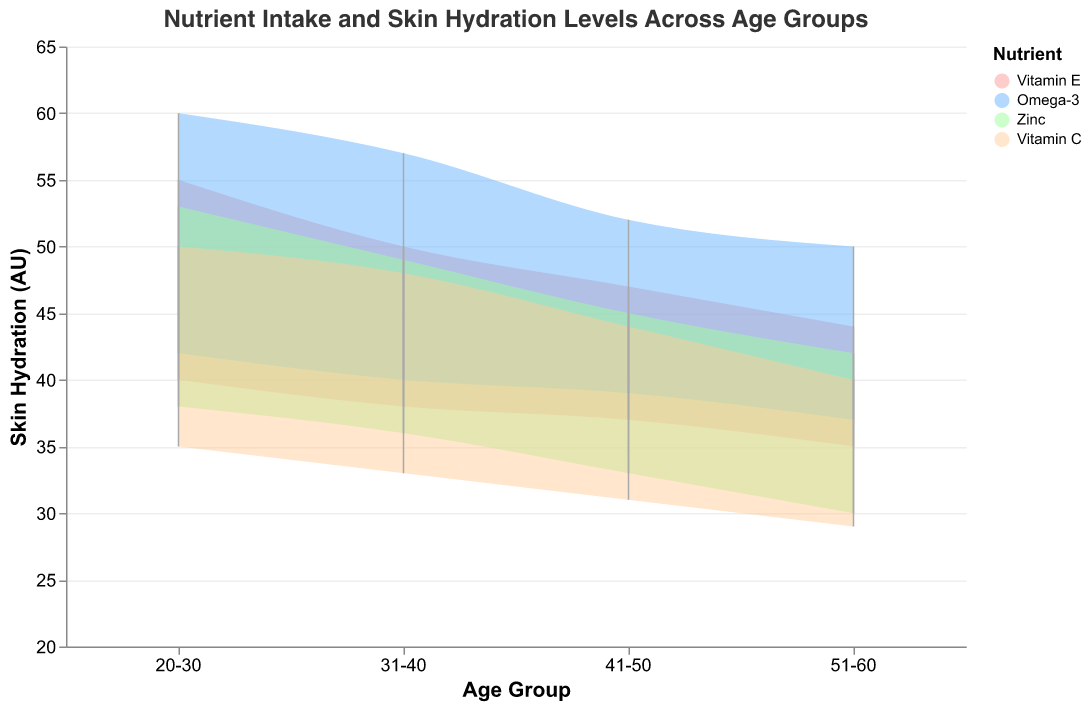What is the title of the chart? The title of the chart is displayed prominently at the top and describes the main purpose of the chart.
Answer: Nutrient Intake and Skin Hydration Levels Across Age Groups Which age group has the highest maximum skin hydration level? By observing the maximum skin hydration levels on the y-axis for each age group, we can compare the peak values. The highest maximum hydration level is evident in the age group where it reaches 60 AU.
Answer: 20-30 How does the range of Vitamin E intake change as age increases? To determine this, we examine the minimum and maximum intake values of Vitamin E from each age group and compare them. As age increases, the range shifts downward for both minimum and maximum intake levels. For instance, in the 20-30 age group, the range is from 8 to 15 mg/day, while in the 51-60 age group, it is from 5 to 12 mg/day.
Answer: It decreases Which nutrient shows the greatest variation in skin hydration levels in the 20-30 age group? The nutrient with the largest range between minimum and maximum skin hydration levels in the 20-30 age group is Omega-3, with a variation from 42 to 60 AU.
Answer: Omega-3 What is the minimum hydration level for the nutrient with the lowest maximum intake in the 41-50 age group? From the data, we see that Zinc has the lowest maximum intake (10 mg/day) in the 41-50 age group. The minimum skin hydration level for Zinc in this age group is 33 AU.
Answer: 33 AU How does the variation in minimum and maximum skin hydration levels for Omega-3 change between the 31-40 and 51-60 age groups? Comparing the ranges from the 31-40 (40-57 AU) and 51-60 (37-50 AU) age groups shows that the range decreases as age increases. Specifically, the variation decreases from 17 AU in 31-40 to 13 AU in 51-60.
Answer: It decreases What is the difference in maximum hydration levels between the nutrients Omega-3 and Vitamin C in the 31-40 age group? By looking at the maximum values for Omega-3 (57 AU) and Vitamin C (48 AU) in the 31-40 age group, we subtract to find the difference: 57 - 48.
Answer: 9 AU Which nutrient has the smallest range of skin hydration levels in the 51-60 age group? By comparing the min and max skin hydration levels for each nutrient in the 51-60 age group, we identify that Zinc has the smallest range (30-42 AU).
Answer: Zinc Is there any age group where the minimum skin hydration level for Vitamin C is higher than the maximum skin hydration level for Zinc? To determine this, we compare the minimum hydration levels of Vitamin C with the maximum hydration levels of Zinc across all age groups. No such case exists where the minimum hydration level of Vitamin C is higher than the maximum hydration level for Zinc.
Answer: No In which age group does Vitamin E have the closest minimum and maximum intake values? Looking at the intake ranges for Vitamin E across age groups, we see the 41-50 age group has the closest values (6 to 13 mg/day), with a range difference of 7 mg/day.
Answer: 41-50 